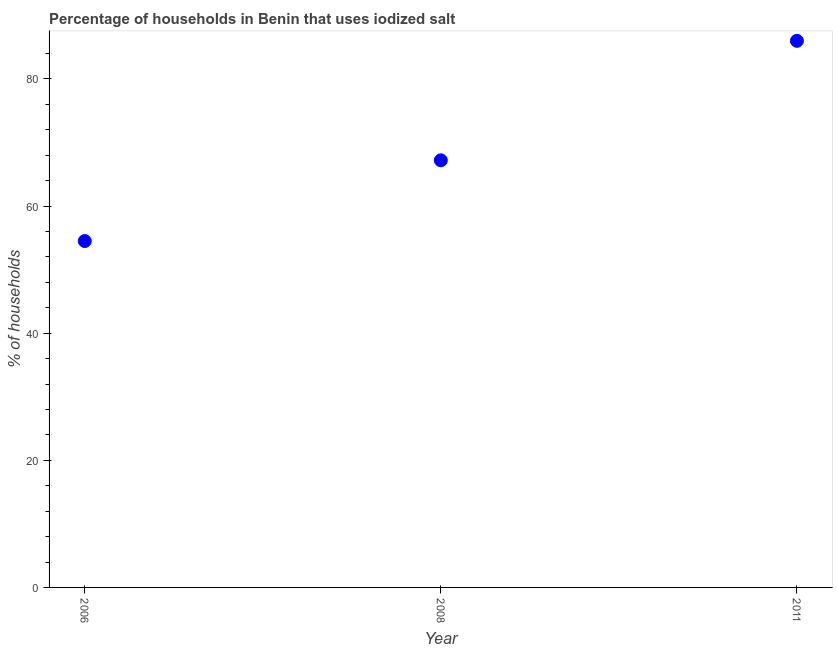What is the percentage of households where iodized salt is consumed in 2011?
Your response must be concise. 86. Across all years, what is the maximum percentage of households where iodized salt is consumed?
Provide a succinct answer. 86. Across all years, what is the minimum percentage of households where iodized salt is consumed?
Your answer should be compact. 54.5. What is the sum of the percentage of households where iodized salt is consumed?
Provide a short and direct response. 207.7. What is the difference between the percentage of households where iodized salt is consumed in 2006 and 2011?
Provide a short and direct response. -31.5. What is the average percentage of households where iodized salt is consumed per year?
Ensure brevity in your answer.  69.23. What is the median percentage of households where iodized salt is consumed?
Make the answer very short. 67.2. In how many years, is the percentage of households where iodized salt is consumed greater than 80 %?
Your answer should be compact. 1. What is the ratio of the percentage of households where iodized salt is consumed in 2006 to that in 2008?
Offer a terse response. 0.81. What is the difference between the highest and the second highest percentage of households where iodized salt is consumed?
Your answer should be very brief. 18.8. What is the difference between the highest and the lowest percentage of households where iodized salt is consumed?
Offer a terse response. 31.5. In how many years, is the percentage of households where iodized salt is consumed greater than the average percentage of households where iodized salt is consumed taken over all years?
Keep it short and to the point. 1. How many dotlines are there?
Give a very brief answer. 1. Are the values on the major ticks of Y-axis written in scientific E-notation?
Your answer should be compact. No. Does the graph contain grids?
Give a very brief answer. No. What is the title of the graph?
Provide a short and direct response. Percentage of households in Benin that uses iodized salt. What is the label or title of the Y-axis?
Provide a short and direct response. % of households. What is the % of households in 2006?
Provide a succinct answer. 54.5. What is the % of households in 2008?
Offer a terse response. 67.2. What is the % of households in 2011?
Ensure brevity in your answer.  86. What is the difference between the % of households in 2006 and 2008?
Provide a succinct answer. -12.7. What is the difference between the % of households in 2006 and 2011?
Your response must be concise. -31.5. What is the difference between the % of households in 2008 and 2011?
Make the answer very short. -18.8. What is the ratio of the % of households in 2006 to that in 2008?
Ensure brevity in your answer.  0.81. What is the ratio of the % of households in 2006 to that in 2011?
Your answer should be very brief. 0.63. What is the ratio of the % of households in 2008 to that in 2011?
Make the answer very short. 0.78. 